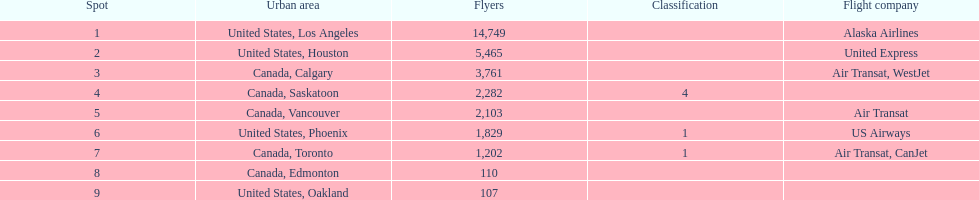The difference in passengers between los angeles and toronto 13,547. 